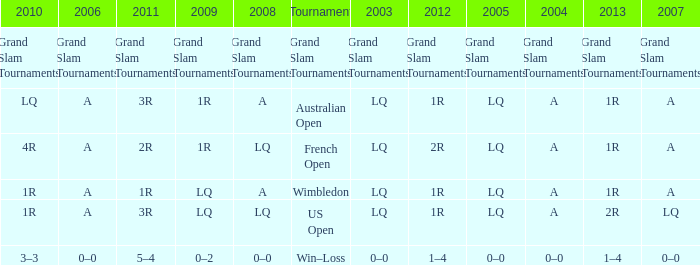Which year has a 2003 of lq? 1R, 1R, LQ, LQ. 